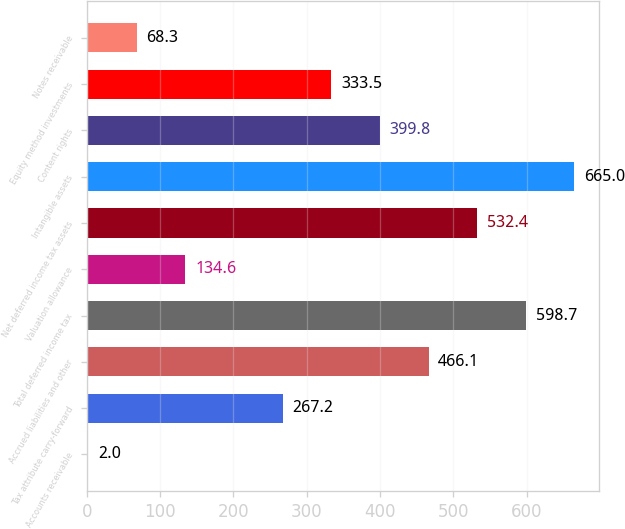<chart> <loc_0><loc_0><loc_500><loc_500><bar_chart><fcel>Accounts receivable<fcel>Tax attribute carry-forward<fcel>Accrued liabilities and other<fcel>Total deferred income tax<fcel>Valuation allowance<fcel>Net deferred income tax assets<fcel>Intangible assets<fcel>Content rights<fcel>Equity method investments<fcel>Notes receivable<nl><fcel>2<fcel>267.2<fcel>466.1<fcel>598.7<fcel>134.6<fcel>532.4<fcel>665<fcel>399.8<fcel>333.5<fcel>68.3<nl></chart> 